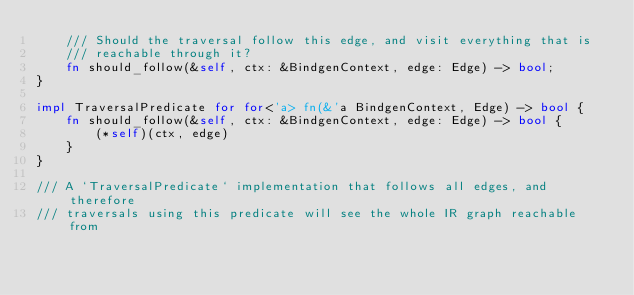<code> <loc_0><loc_0><loc_500><loc_500><_Rust_>    /// Should the traversal follow this edge, and visit everything that is
    /// reachable through it?
    fn should_follow(&self, ctx: &BindgenContext, edge: Edge) -> bool;
}

impl TraversalPredicate for for<'a> fn(&'a BindgenContext, Edge) -> bool {
    fn should_follow(&self, ctx: &BindgenContext, edge: Edge) -> bool {
        (*self)(ctx, edge)
    }
}

/// A `TraversalPredicate` implementation that follows all edges, and therefore
/// traversals using this predicate will see the whole IR graph reachable from</code> 